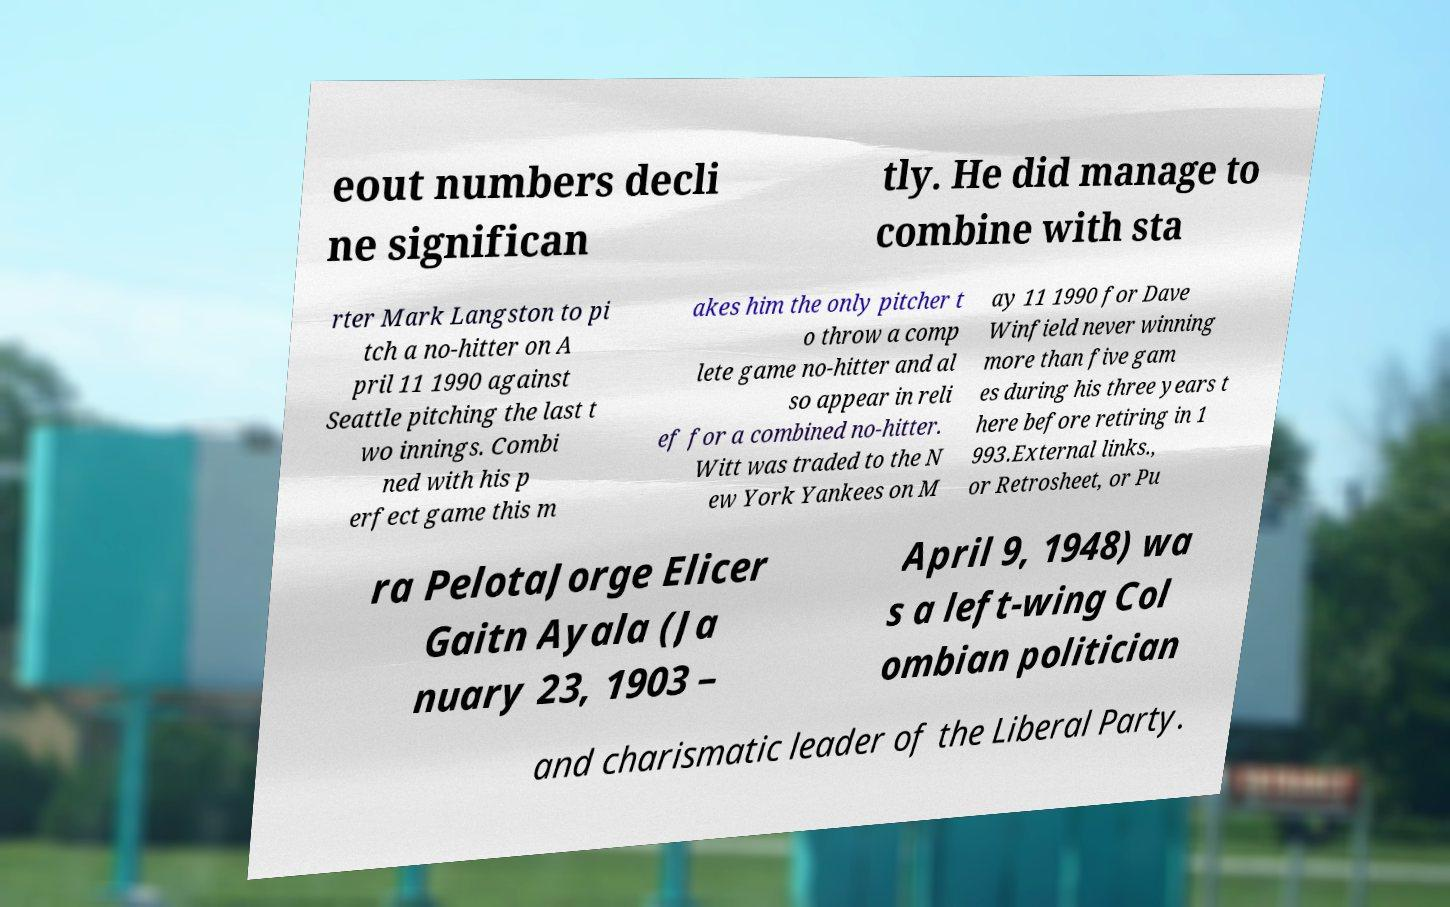Could you assist in decoding the text presented in this image and type it out clearly? eout numbers decli ne significan tly. He did manage to combine with sta rter Mark Langston to pi tch a no-hitter on A pril 11 1990 against Seattle pitching the last t wo innings. Combi ned with his p erfect game this m akes him the only pitcher t o throw a comp lete game no-hitter and al so appear in reli ef for a combined no-hitter. Witt was traded to the N ew York Yankees on M ay 11 1990 for Dave Winfield never winning more than five gam es during his three years t here before retiring in 1 993.External links., or Retrosheet, or Pu ra PelotaJorge Elicer Gaitn Ayala (Ja nuary 23, 1903 – April 9, 1948) wa s a left-wing Col ombian politician and charismatic leader of the Liberal Party. 